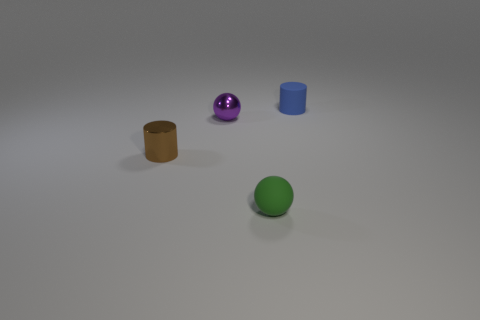What number of objects are small cyan matte spheres or tiny metallic objects right of the small brown cylinder?
Offer a very short reply. 1. Are there more small brown objects that are right of the purple metallic object than brown metal cylinders?
Make the answer very short. No. Are there an equal number of blue rubber cylinders behind the small blue rubber cylinder and blue rubber objects in front of the purple shiny ball?
Your answer should be very brief. Yes. There is a cylinder behind the brown metallic thing; are there any small brown shiny cylinders behind it?
Offer a terse response. No. What is the shape of the brown metallic object?
Ensure brevity in your answer.  Cylinder. There is a cylinder in front of the small cylinder that is to the right of the green rubber object; what is its size?
Offer a very short reply. Small. What size is the cylinder that is to the right of the tiny purple thing?
Make the answer very short. Small. Are there fewer tiny green matte objects that are behind the tiny purple metal thing than objects to the left of the tiny green sphere?
Offer a terse response. Yes. What is the color of the shiny ball?
Provide a short and direct response. Purple. Is there a tiny metallic cylinder that has the same color as the metal sphere?
Your response must be concise. No. 